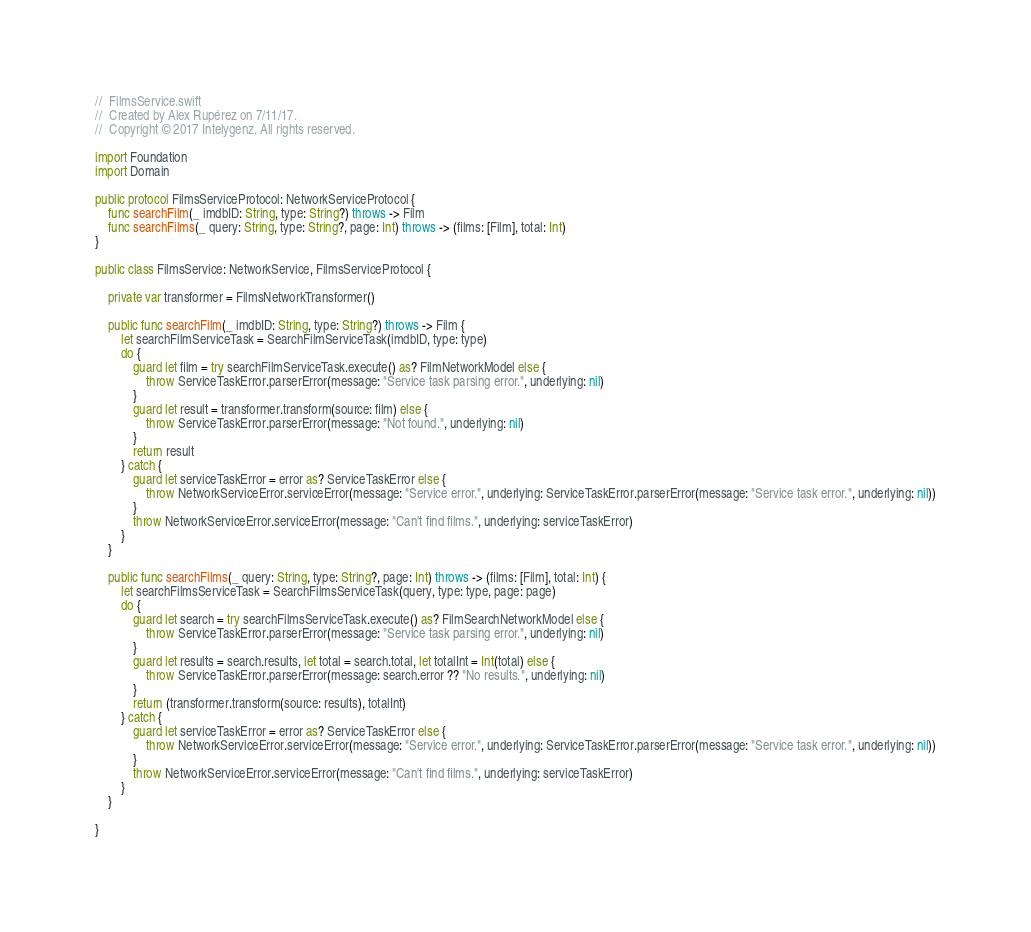<code> <loc_0><loc_0><loc_500><loc_500><_Swift_>//  FilmsService.swift
//  Created by Alex Rupérez on 7/11/17.
//  Copyright © 2017 Intelygenz. All rights reserved.

import Foundation
import Domain

public protocol FilmsServiceProtocol: NetworkServiceProtocol {
    func searchFilm(_ imdbID: String, type: String?) throws -> Film
    func searchFilms(_ query: String, type: String?, page: Int) throws -> (films: [Film], total: Int)
}

public class FilmsService: NetworkService, FilmsServiceProtocol {

    private var transformer = FilmsNetworkTransformer()

    public func searchFilm(_ imdbID: String, type: String?) throws -> Film {
        let searchFilmServiceTask = SearchFilmServiceTask(imdbID, type: type)
        do {
            guard let film = try searchFilmServiceTask.execute() as? FilmNetworkModel else {
                throw ServiceTaskError.parserError(message: "Service task parsing error.", underlying: nil)
            }
            guard let result = transformer.transform(source: film) else {
                throw ServiceTaskError.parserError(message: "Not found.", underlying: nil)
            }
            return result
        } catch {
            guard let serviceTaskError = error as? ServiceTaskError else {
                throw NetworkServiceError.serviceError(message: "Service error.", underlying: ServiceTaskError.parserError(message: "Service task error.", underlying: nil))
            }
            throw NetworkServiceError.serviceError(message: "Can't find films.", underlying: serviceTaskError)
        }
    }

    public func searchFilms(_ query: String, type: String?, page: Int) throws -> (films: [Film], total: Int) {
        let searchFilmsServiceTask = SearchFilmsServiceTask(query, type: type, page: page)
        do {
            guard let search = try searchFilmsServiceTask.execute() as? FilmSearchNetworkModel else {
                throw ServiceTaskError.parserError(message: "Service task parsing error.", underlying: nil)
            }
            guard let results = search.results, let total = search.total, let totalInt = Int(total) else {
                throw ServiceTaskError.parserError(message: search.error ?? "No results.", underlying: nil)
            }
            return (transformer.transform(source: results), totalInt)
        } catch {
            guard let serviceTaskError = error as? ServiceTaskError else {
                throw NetworkServiceError.serviceError(message: "Service error.", underlying: ServiceTaskError.parserError(message: "Service task error.", underlying: nil))
            }
            throw NetworkServiceError.serviceError(message: "Can't find films.", underlying: serviceTaskError)
        }
    }

}
</code> 